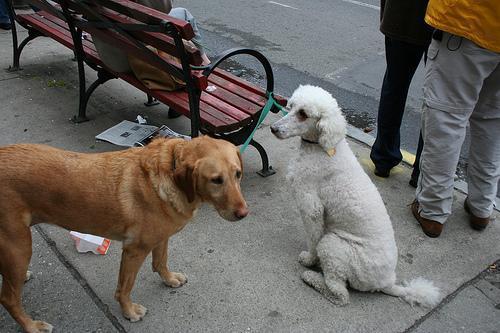How many dogs are sitting down?
Give a very brief answer. 1. 